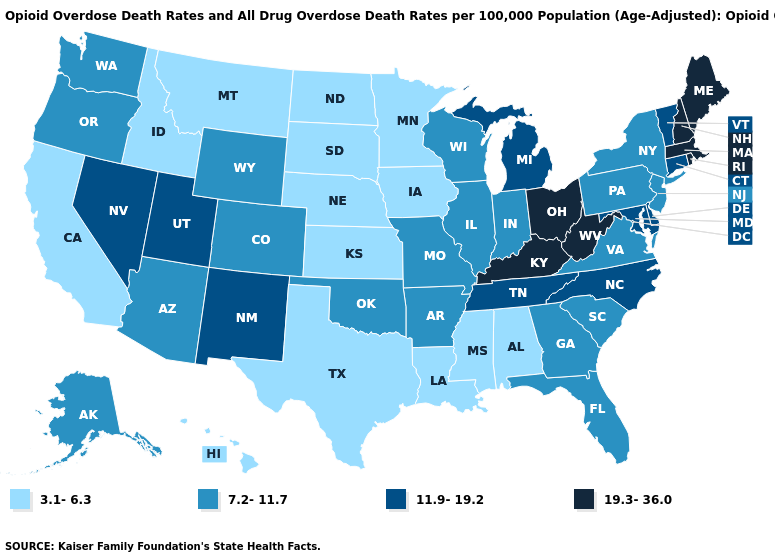Name the states that have a value in the range 11.9-19.2?
Answer briefly. Connecticut, Delaware, Maryland, Michigan, Nevada, New Mexico, North Carolina, Tennessee, Utah, Vermont. Name the states that have a value in the range 3.1-6.3?
Quick response, please. Alabama, California, Hawaii, Idaho, Iowa, Kansas, Louisiana, Minnesota, Mississippi, Montana, Nebraska, North Dakota, South Dakota, Texas. What is the value of Florida?
Concise answer only. 7.2-11.7. What is the value of New York?
Be succinct. 7.2-11.7. Does Missouri have a higher value than Iowa?
Concise answer only. Yes. What is the value of New York?
Short answer required. 7.2-11.7. What is the value of Minnesota?
Short answer required. 3.1-6.3. Among the states that border Massachusetts , does Rhode Island have the highest value?
Be succinct. Yes. Among the states that border California , which have the highest value?
Write a very short answer. Nevada. Which states have the highest value in the USA?
Be succinct. Kentucky, Maine, Massachusetts, New Hampshire, Ohio, Rhode Island, West Virginia. Does Pennsylvania have a lower value than North Dakota?
Give a very brief answer. No. What is the value of Georgia?
Concise answer only. 7.2-11.7. Does Oklahoma have a higher value than Michigan?
Write a very short answer. No. What is the highest value in the USA?
Keep it brief. 19.3-36.0. Among the states that border Colorado , does Utah have the highest value?
Short answer required. Yes. 